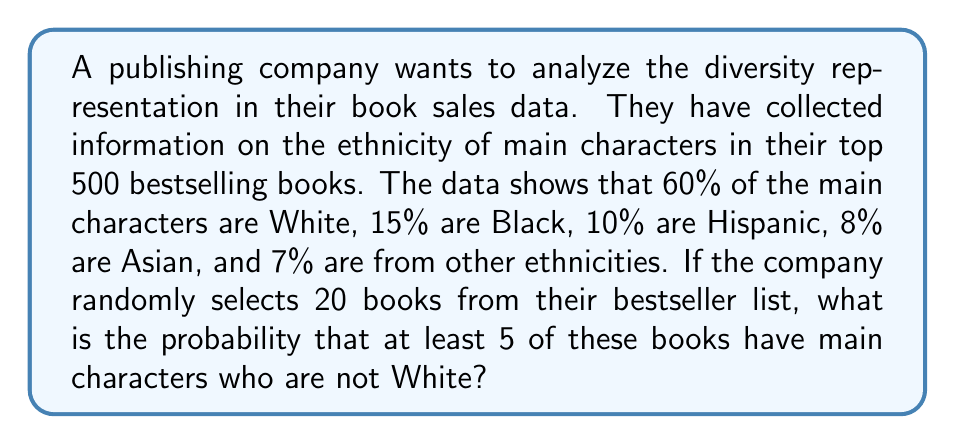Can you solve this math problem? To solve this problem, we'll use the binomial probability distribution.

Step 1: Identify the parameters
- n (number of trials) = 20 books
- p (probability of success) = 1 - 0.60 = 0.40 (probability of a non-White main character)
- q (probability of failure) = 1 - p = 0.60

Step 2: We need to find P(X ≥ 5), where X is the number of books with non-White main characters.

Step 3: It's easier to calculate P(X < 5) and then subtract from 1:
P(X ≥ 5) = 1 - P(X < 5) = 1 - [P(X = 0) + P(X = 1) + P(X = 2) + P(X = 3) + P(X = 4)]

Step 4: Use the binomial probability formula for each term:
P(X = k) = $\binom{n}{k} p^k q^{n-k}$

P(X = 0) = $\binom{20}{0} (0.40)^0 (0.60)^{20} = 0.0037$
P(X = 1) = $\binom{20}{1} (0.40)^1 (0.60)^{19} = 0.0148$
P(X = 2) = $\binom{20}{2} (0.40)^2 (0.60)^{18} = 0.0296$
P(X = 3) = $\binom{20}{3} (0.40)^3 (0.60)^{17} = 0.0395$
P(X = 4) = $\binom{20}{4} (0.40)^4 (0.60)^{16} = 0.0395$

Step 5: Sum these probabilities:
P(X < 5) = 0.0037 + 0.0148 + 0.0296 + 0.0395 + 0.0395 = 0.1271

Step 6: Calculate the final probability:
P(X ≥ 5) = 1 - P(X < 5) = 1 - 0.1271 = 0.8729

Therefore, the probability of selecting at least 5 books with non-White main characters out of 20 randomly selected bestsellers is approximately 0.8729 or 87.29%.
Answer: 0.8729 